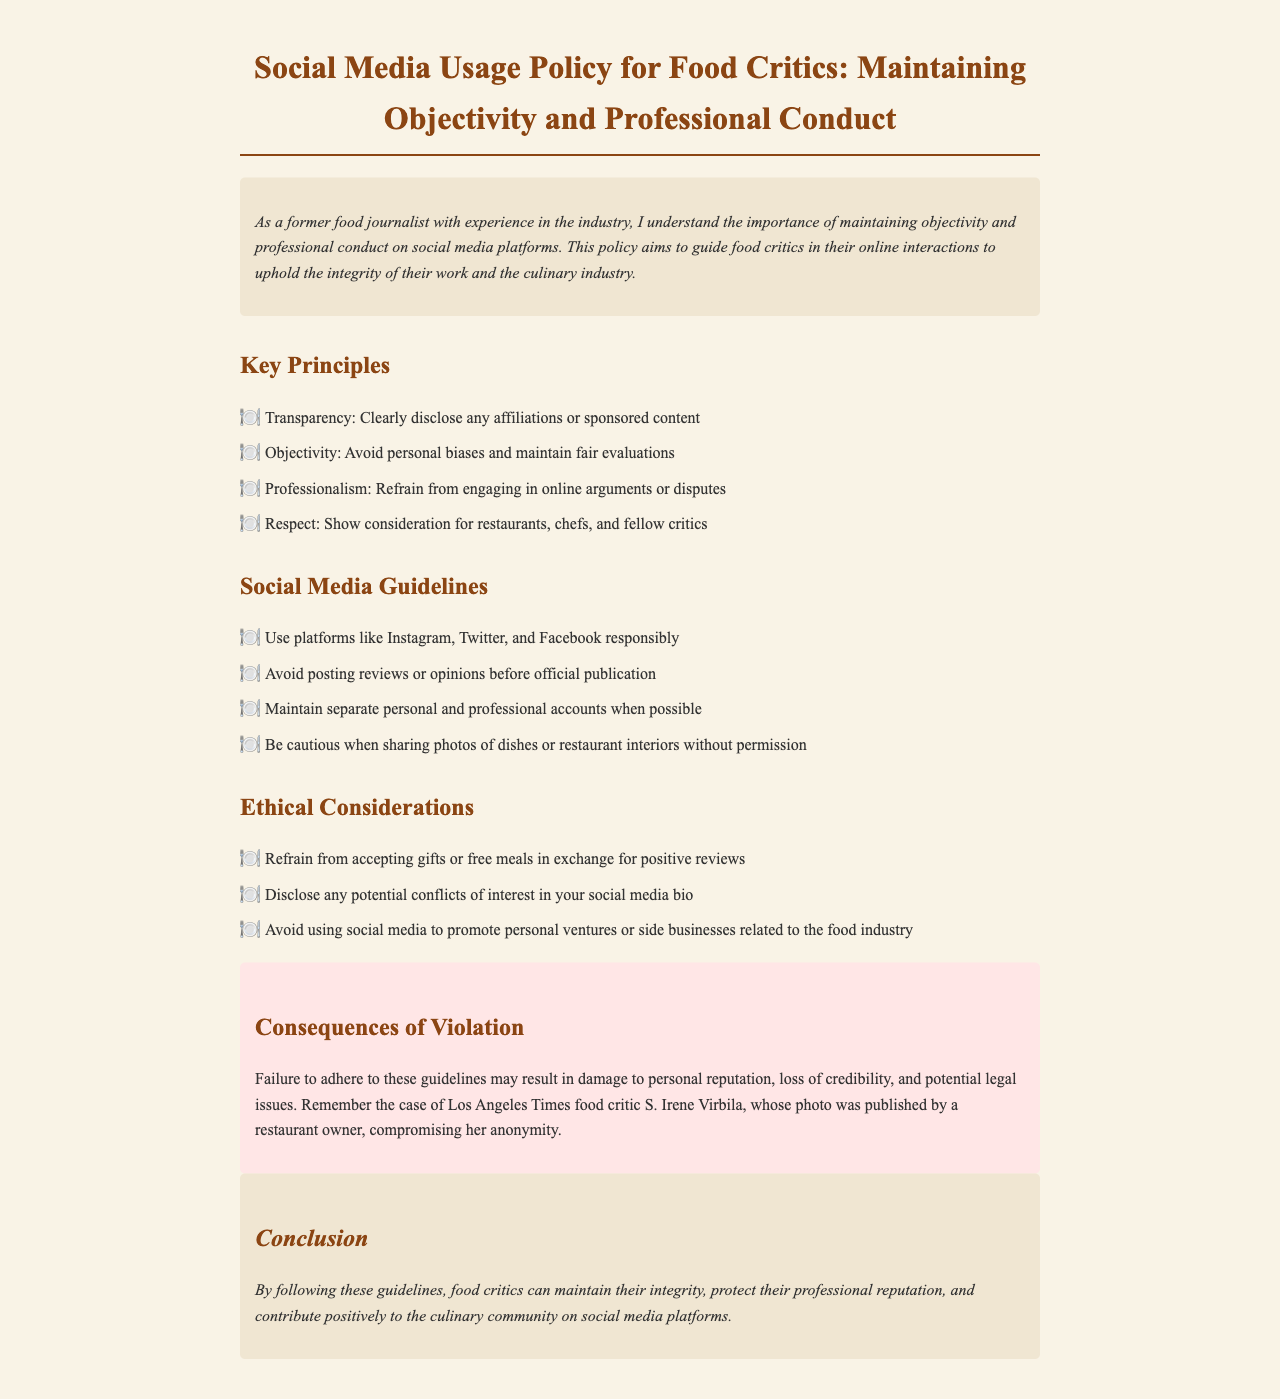What is the title of the document? The title is provided in the header of the document.
Answer: Social Media Usage Policy for Food Critics: Maintaining Objectivity and Professional Conduct What is one key principle mentioned in the document? Key principles are listed under the "Key Principles" section of the document.
Answer: Transparency How many social media platforms are mentioned in the guidelines? The guidelines list specific platforms that food critics should use.
Answer: Three What should food critics do before posting reviews on social media? The document states guidelines regarding the timing of posting reviews.
Answer: Wait for official publication What is a potential consequence of violating the guidelines? The consequences are outlined in the "Consequences of Violation" section.
Answer: Damage to personal reputation What should critics refrain from accepting according to ethical considerations? The ethical considerations specify certain actions critics should avoid.
Answer: Gifts or free meals What is a recommended practice for handling personal and professional accounts? The document provides guidance on account management under social media guidelines.
Answer: Maintain separate accounts What should be disclosed in a critic's social media bio? Ethical considerations mention specific disclosures required in social media bios.
Answer: Potential conflicts of interest 